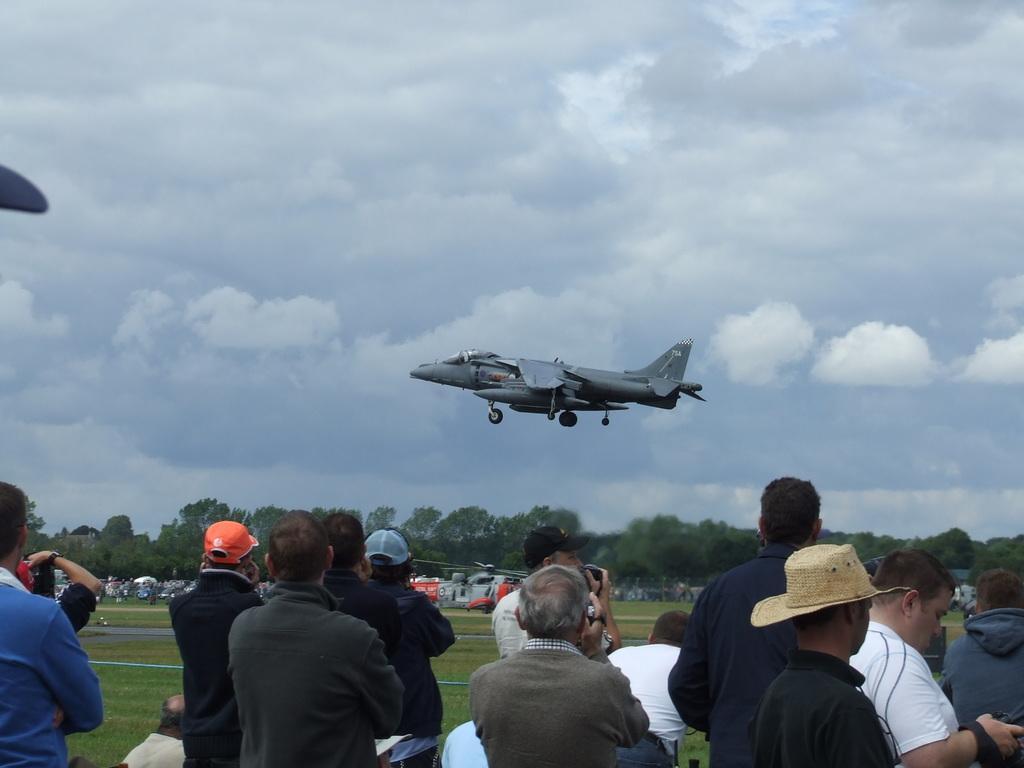How would you summarize this image in a sentence or two? In this image I can see an open grass ground and on it I can see number of people are standing. I can also see an aircraft in the air and in the background I can see number of trees, clouds and the sky. In the front I can see few people are wearing caps. 